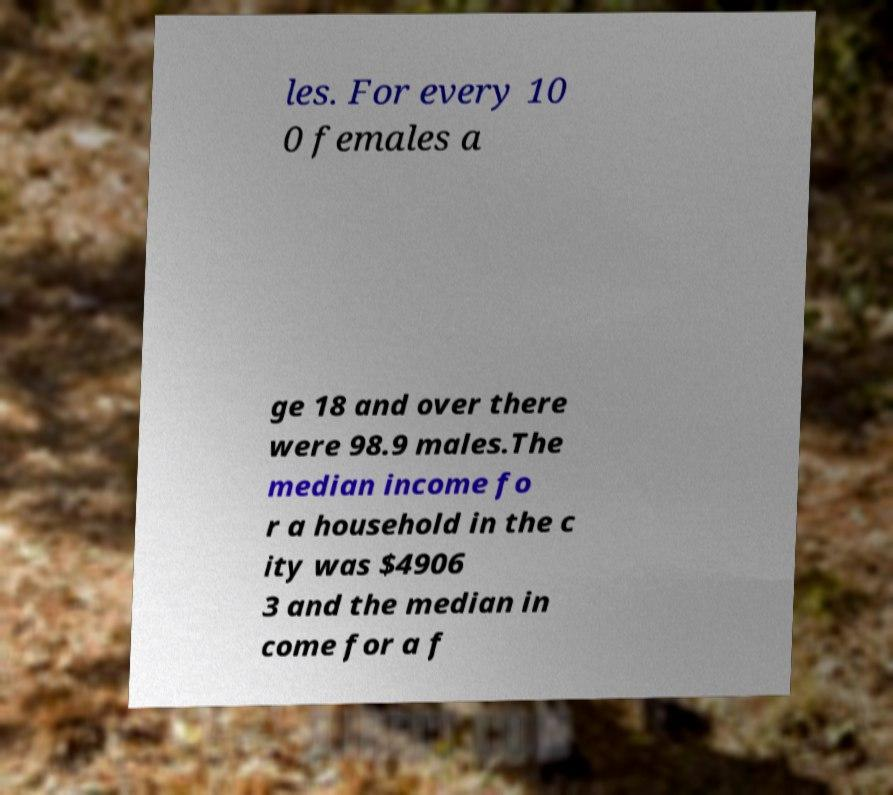Please read and relay the text visible in this image. What does it say? les. For every 10 0 females a ge 18 and over there were 98.9 males.The median income fo r a household in the c ity was $4906 3 and the median in come for a f 